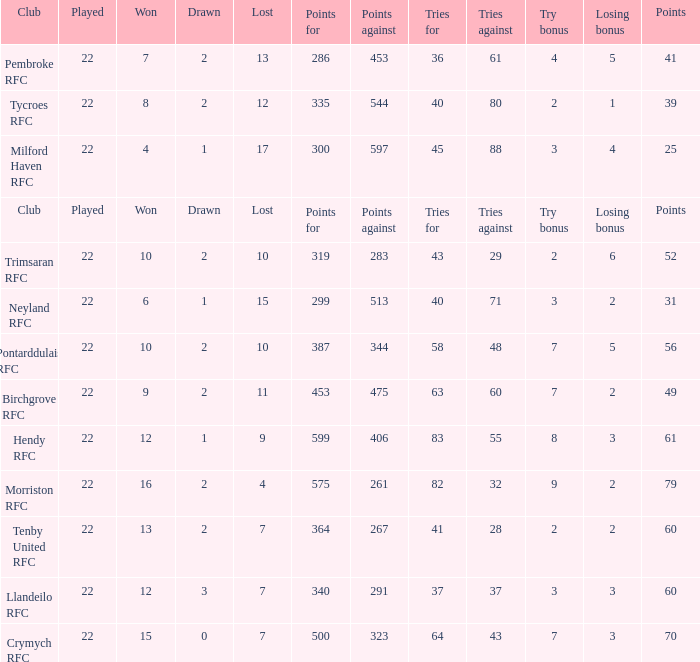What's the club with losing bonus being 1 Tycroes RFC. 